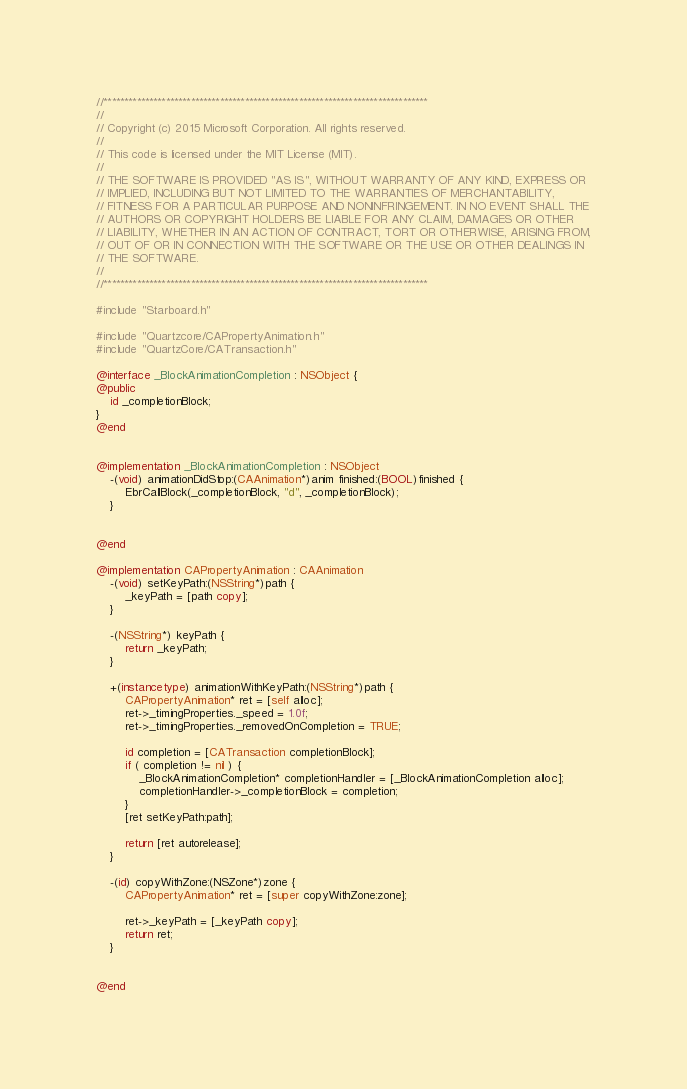Convert code to text. <code><loc_0><loc_0><loc_500><loc_500><_ObjectiveC_>//******************************************************************************
//
// Copyright (c) 2015 Microsoft Corporation. All rights reserved.
//
// This code is licensed under the MIT License (MIT).
//
// THE SOFTWARE IS PROVIDED "AS IS", WITHOUT WARRANTY OF ANY KIND, EXPRESS OR
// IMPLIED, INCLUDING BUT NOT LIMITED TO THE WARRANTIES OF MERCHANTABILITY,
// FITNESS FOR A PARTICULAR PURPOSE AND NONINFRINGEMENT. IN NO EVENT SHALL THE
// AUTHORS OR COPYRIGHT HOLDERS BE LIABLE FOR ANY CLAIM, DAMAGES OR OTHER
// LIABILITY, WHETHER IN AN ACTION OF CONTRACT, TORT OR OTHERWISE, ARISING FROM,
// OUT OF OR IN CONNECTION WITH THE SOFTWARE OR THE USE OR OTHER DEALINGS IN
// THE SOFTWARE.
//
//******************************************************************************

#include "Starboard.h"

#include "Quartzcore/CAPropertyAnimation.h"
#include "QuartzCore/CATransaction.h"

@interface _BlockAnimationCompletion : NSObject {
@public
    id _completionBlock;
}
@end


@implementation _BlockAnimationCompletion : NSObject
    -(void) animationDidStop:(CAAnimation*)anim finished:(BOOL)finished {
        EbrCallBlock(_completionBlock, "d", _completionBlock);
    }

    
@end

@implementation CAPropertyAnimation : CAAnimation
    -(void) setKeyPath:(NSString*)path {
        _keyPath = [path copy];
    }

    -(NSString*) keyPath {
        return _keyPath;
    }

    +(instancetype) animationWithKeyPath:(NSString*)path {
        CAPropertyAnimation* ret = [self alloc];
        ret->_timingProperties._speed = 1.0f;
        ret->_timingProperties._removedOnCompletion = TRUE;

        id completion = [CATransaction completionBlock];
        if ( completion != nil ) {
            _BlockAnimationCompletion* completionHandler = [_BlockAnimationCompletion alloc];
            completionHandler->_completionBlock = completion;
        }
        [ret setKeyPath:path];

        return [ret autorelease];
    }

    -(id) copyWithZone:(NSZone*)zone {
        CAPropertyAnimation* ret = [super copyWithZone:zone];

        ret->_keyPath = [_keyPath copy];
        return ret;
    }

    
@end

</code> 